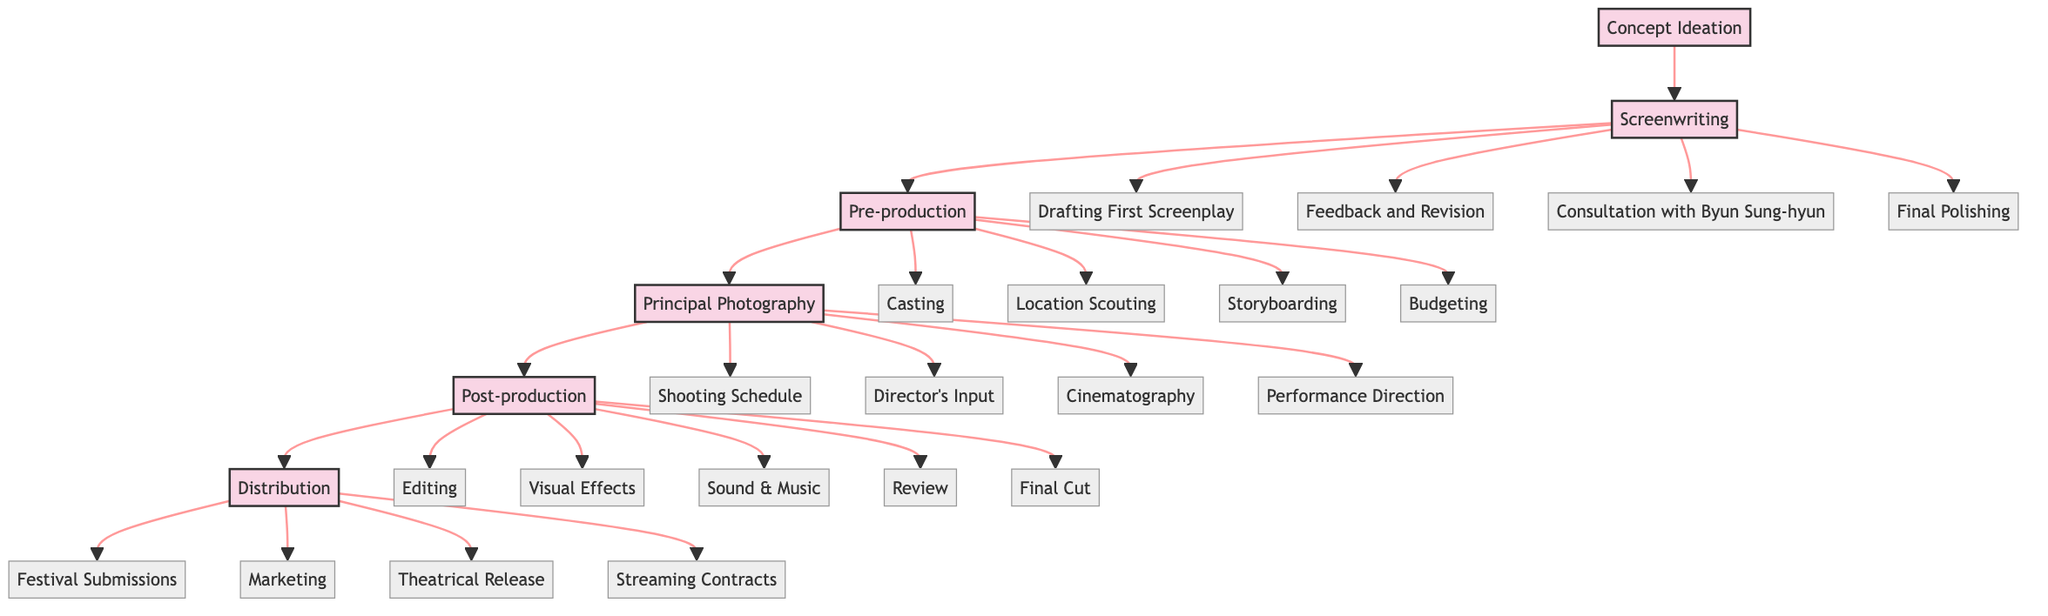What's the first stage in the development pathway? The diagram shows that the first stage in the development pathway is "Concept Ideation." This is represented at the beginning of the flow, leading into the next stage.
Answer: Concept Ideation How many detailed steps are there in the Screenwriting stage? In the diagram, the Screenwriting stage branches into four detailed steps: Drafting First Screenplay, Feedback and Revision, Consultation with Byun Sung-hyun, and Final Polishing. Counting these gives us a total of four detailed steps.
Answer: 4 What follows Principal Photography in the development pathway? By tracing the flow from the Principal Photography stage, the next stage in the diagram is Post-production. This indicates the sequential flow of the development pathway.
Answer: Post-production Which stage includes "Festival Submissions"? The distribution stage in the diagram specifically includes "Festival Submissions" as one of its detailed steps. This can be identified by looking at the last stage of the pathway and its sub-nodes.
Answer: Distribution In how many stages does "Feedback and Revision" appear? By examining the diagram, "Feedback and Revision" is a detailed step within the "Screenwriting" stage, and it does not appear in any other stage, thus counting it yields a total of one appearance.
Answer: 1 What is the role of "Director's Artistic Input" in the development pathway? The "Director's Artistic Input" is a detailed step found within the "Principal Photography" stage. This indicates the role of the director during the filming process and shows the level of creative involvement at this stage.
Answer: Principal Photography Which stage is directly connected to the final output of the film? The "Distribution" stage is the final output stage in the diagram, connected to the preceding Post-production stage, indicating that this is where the final product is shared with the audience.
Answer: Distribution List the detailed steps in Post-production. In the diagram, the Post-production stage contains five detailed steps: Editing First Cut, Visual Effects Integration, Sound Design and Music Score, Peer and Mentor Review, and Final Cut Approval. By identifying all these steps leads to the answer.
Answer: Editing First Cut, Visual Effects Integration, Sound Design and Music Score, Peer and Mentor Review, Final Cut Approval How many main stages are in the development pathway? By analyzing the flowchart, there are five main stages from Concept Ideation to Distribution, as visually represented, which indicates the overall structure of the development pathway.
Answer: 5 